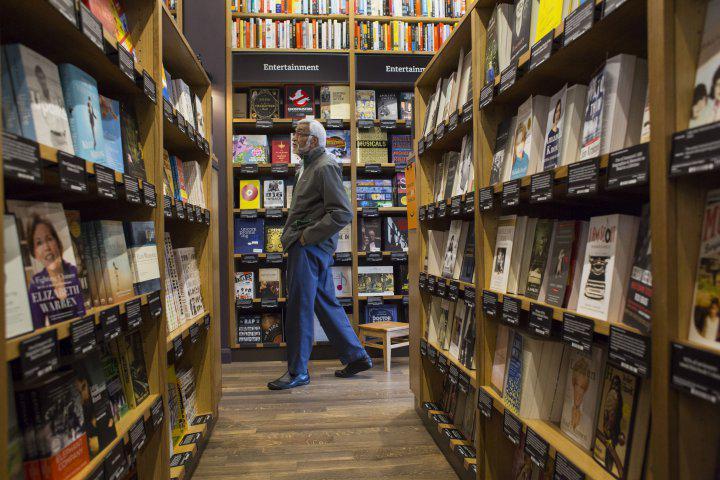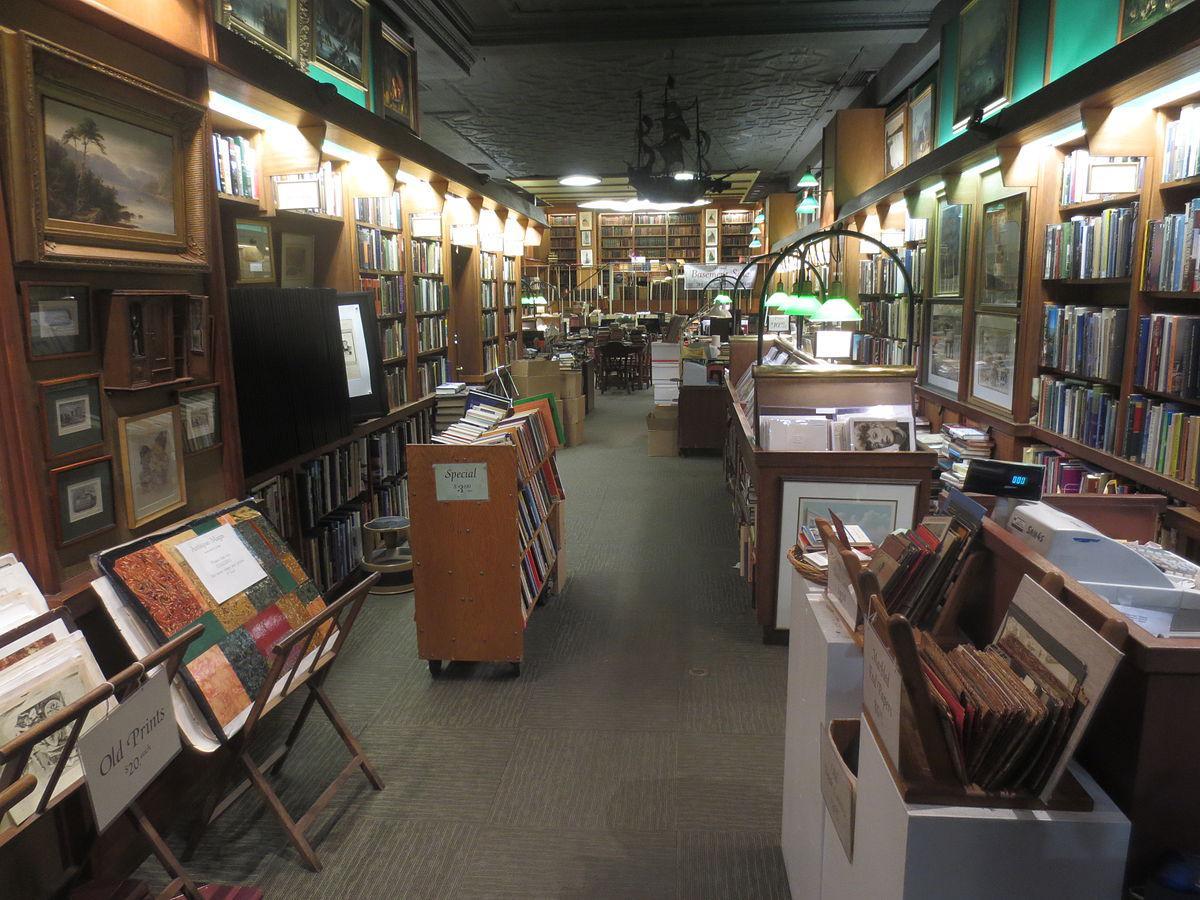The first image is the image on the left, the second image is the image on the right. Evaluate the accuracy of this statement regarding the images: "There are at least two chairs.". Is it true? Answer yes or no. No. 